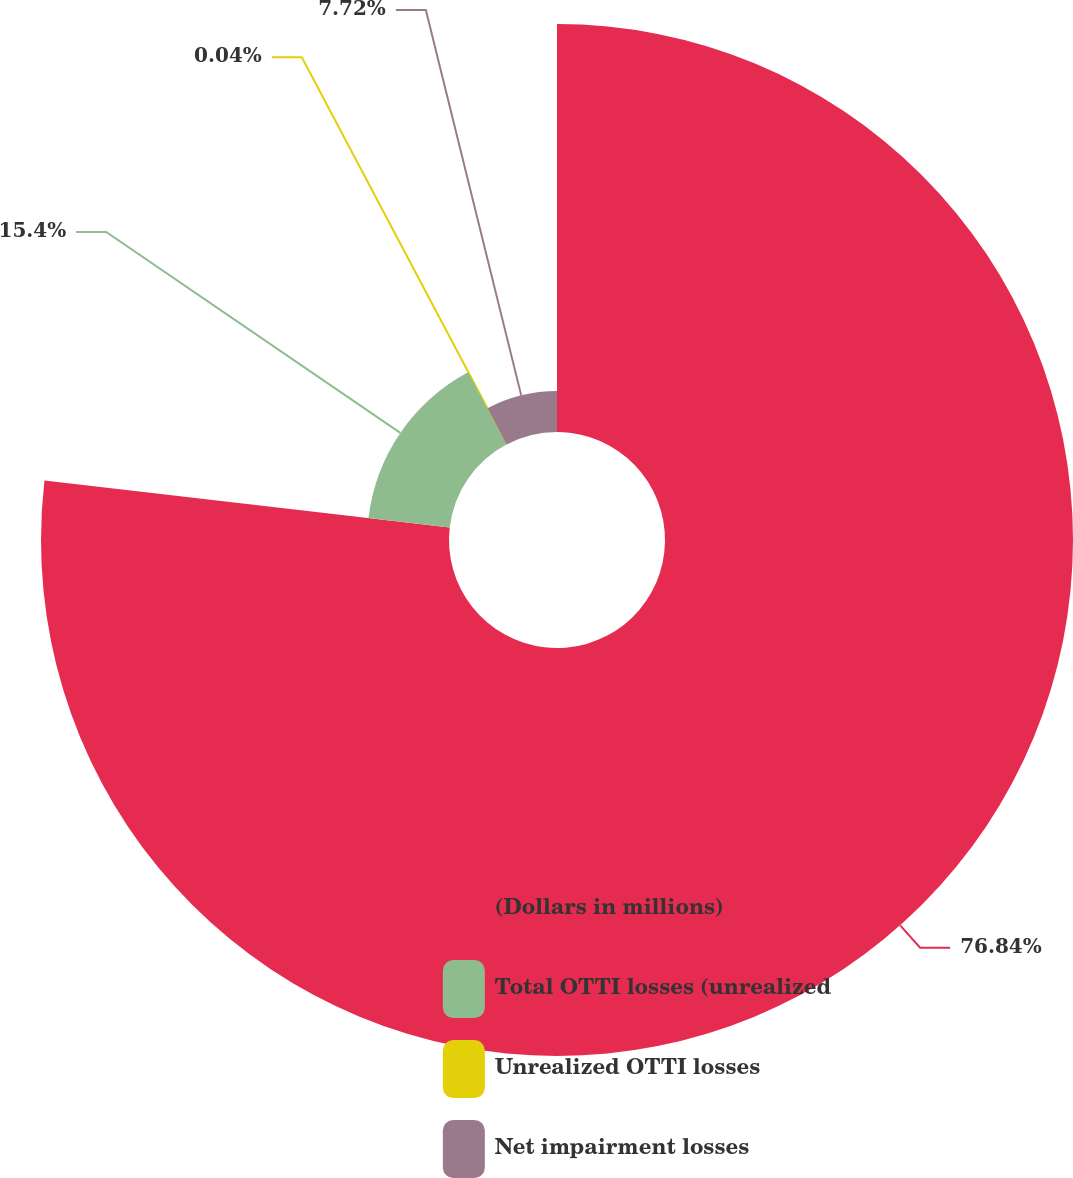Convert chart to OTSL. <chart><loc_0><loc_0><loc_500><loc_500><pie_chart><fcel>(Dollars in millions)<fcel>Total OTTI losses (unrealized<fcel>Unrealized OTTI losses<fcel>Net impairment losses<nl><fcel>76.84%<fcel>15.4%<fcel>0.04%<fcel>7.72%<nl></chart> 